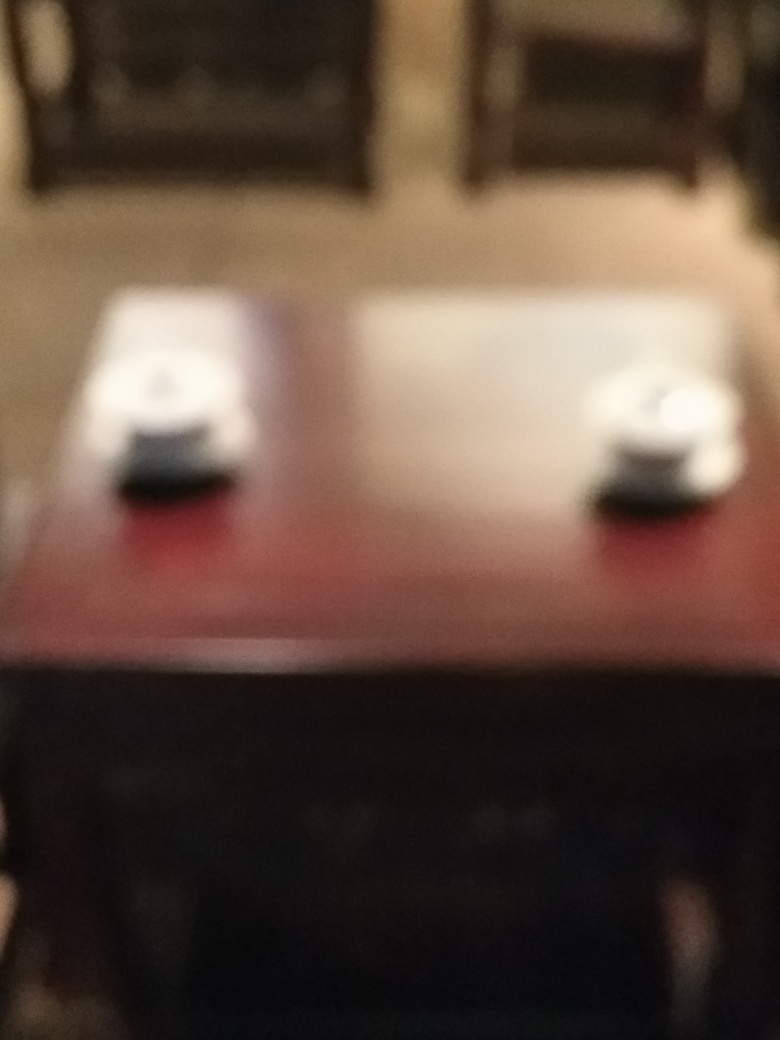What mood does this image evoke? Although the image is blurry, there's a sense of stillness and quiet that may evoke a feeling of solitude or introspection. The dim lighting and the blurred shapes contribute to a somewhat somber or mysterious atmosphere. 